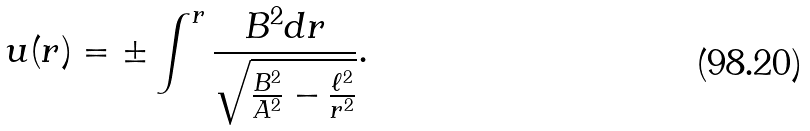Convert formula to latex. <formula><loc_0><loc_0><loc_500><loc_500>u ( r ) = \pm \int ^ { r } \frac { B ^ { 2 } d r } { \sqrt { \frac { B ^ { 2 } } { A ^ { 2 } } - \frac { \ell ^ { 2 } } { r ^ { 2 } } } } .</formula> 